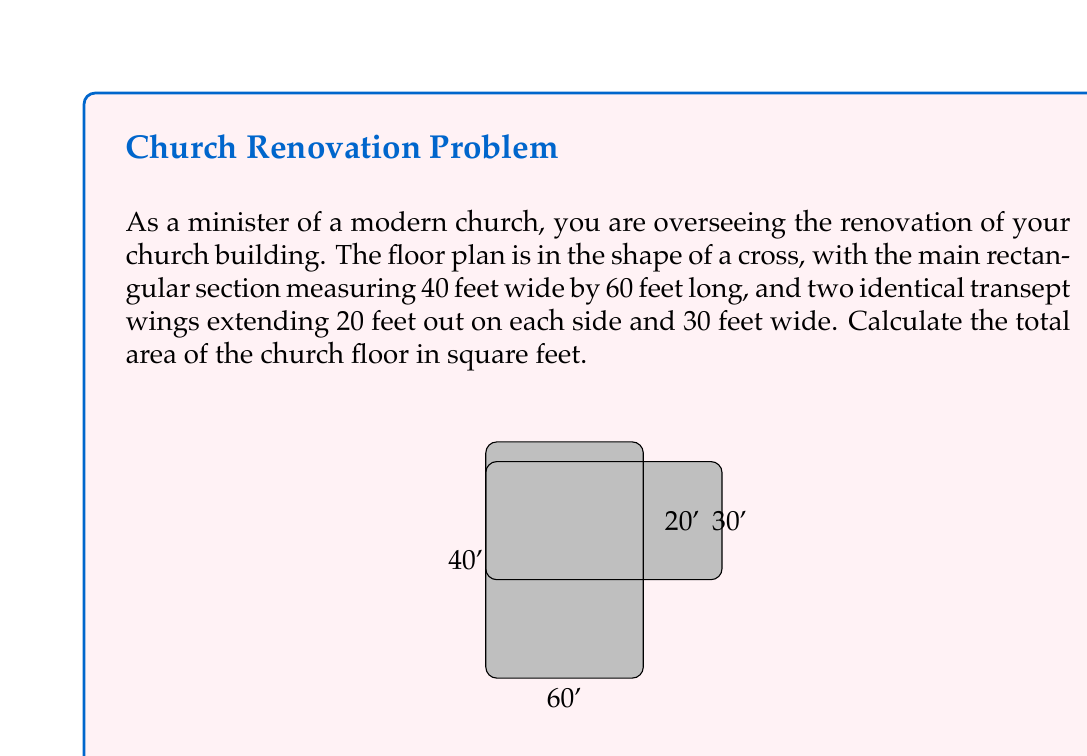Give your solution to this math problem. To calculate the total area of the cross-shaped church floor, we need to break it down into rectangular sections and add their areas together. Let's approach this step-by-step:

1) First, calculate the area of the main rectangular section:
   $$ A_{main} = 40 \text{ ft} \times 60 \text{ ft} = 2400 \text{ sq ft} $$

2) Next, calculate the area of one transept wing:
   $$ A_{wing} = 20 \text{ ft} \times 30 \text{ ft} = 600 \text{ sq ft} $$

3) Since there are two identical transept wings, we multiply this area by 2:
   $$ A_{wings} = 2 \times 600 \text{ sq ft} = 1200 \text{ sq ft} $$

4) The total area is the sum of the main section and both wings:
   $$ A_{total} = A_{main} + A_{wings} $$
   $$ A_{total} = 2400 \text{ sq ft} + 1200 \text{ sq ft} = 3600 \text{ sq ft} $$

Therefore, the total area of the church floor is 3600 square feet.
Answer: $$ A_{total} = 3600 \text{ sq ft} $$ 